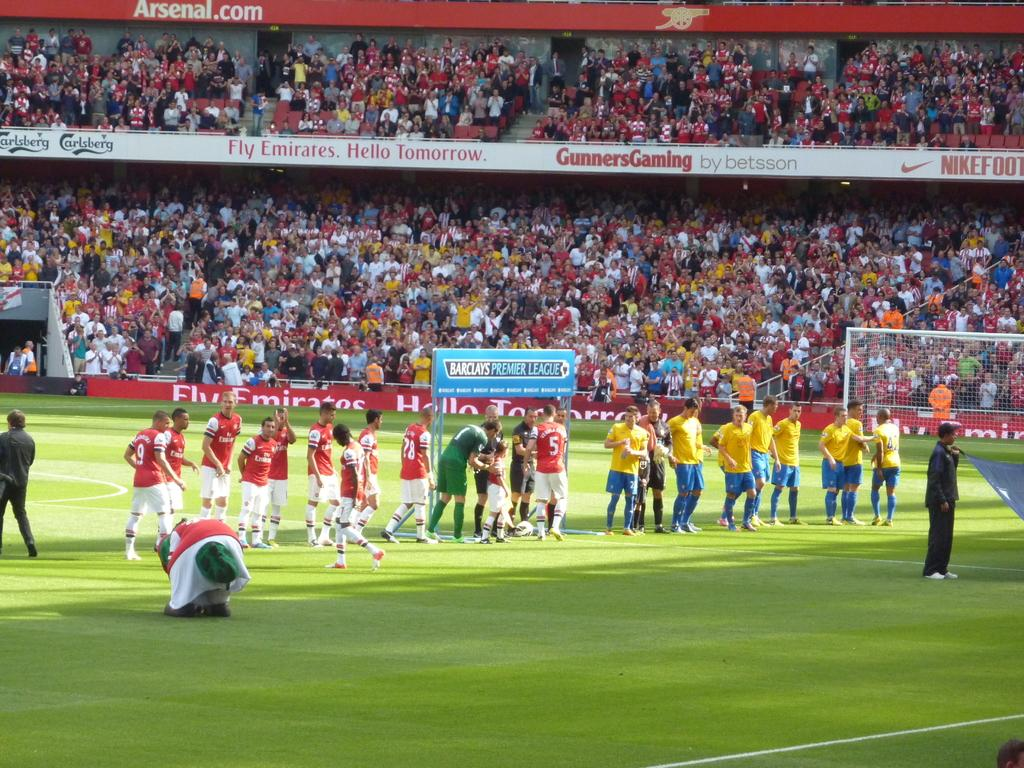<image>
Relay a brief, clear account of the picture shown. The professional soccer league is being sponsored by Barclays and Emirates. 